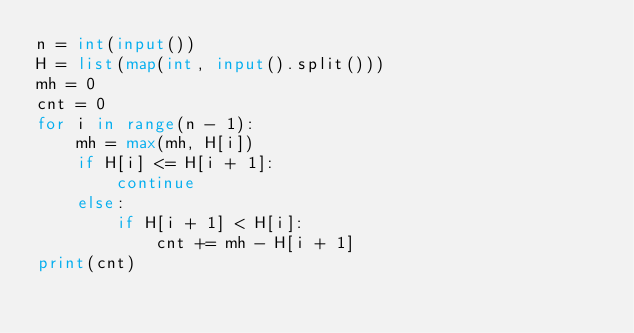<code> <loc_0><loc_0><loc_500><loc_500><_Python_>n = int(input())
H = list(map(int, input().split()))
mh = 0
cnt = 0
for i in range(n - 1):
    mh = max(mh, H[i])
    if H[i] <= H[i + 1]:
        continue
    else:
        if H[i + 1] < H[i]:
            cnt += mh - H[i + 1]
print(cnt)
</code> 